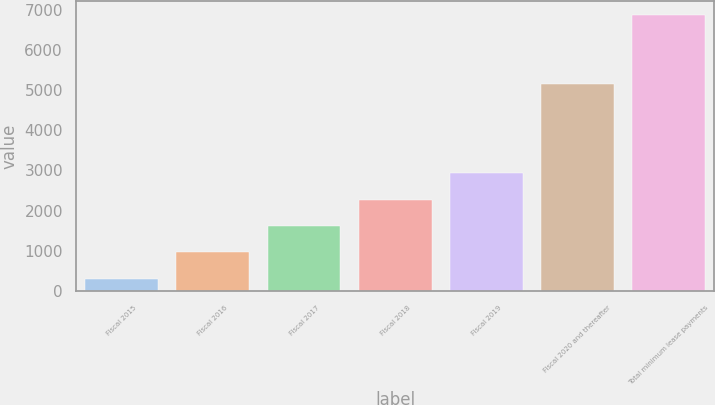Convert chart. <chart><loc_0><loc_0><loc_500><loc_500><bar_chart><fcel>Fiscal 2015<fcel>Fiscal 2016<fcel>Fiscal 2017<fcel>Fiscal 2018<fcel>Fiscal 2019<fcel>Fiscal 2020 and thereafter<fcel>Total minimum lease payments<nl><fcel>304<fcel>959.8<fcel>1615.6<fcel>2271.4<fcel>2927.2<fcel>5163<fcel>6862<nl></chart> 